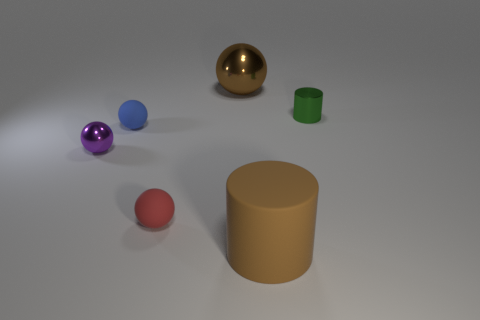How many brown objects are either big matte cylinders or matte spheres?
Your response must be concise. 1. The cylinder that is made of the same material as the red sphere is what size?
Your answer should be compact. Large. Is the large object that is in front of the small green shiny object made of the same material as the sphere that is in front of the tiny purple thing?
Your response must be concise. Yes. How many cylinders are either small green matte things or green things?
Your answer should be very brief. 1. How many cylinders are behind the tiny matte sphere that is right of the rubber ball that is behind the red rubber ball?
Your answer should be compact. 1. What is the material of the other big object that is the same shape as the green shiny object?
Offer a terse response. Rubber. What is the color of the cylinder that is in front of the green metallic object?
Offer a very short reply. Brown. Are the tiny green cylinder and the big brown object that is in front of the large shiny thing made of the same material?
Offer a very short reply. No. What is the tiny purple object made of?
Offer a very short reply. Metal. The small green thing that is the same material as the small purple thing is what shape?
Make the answer very short. Cylinder. 